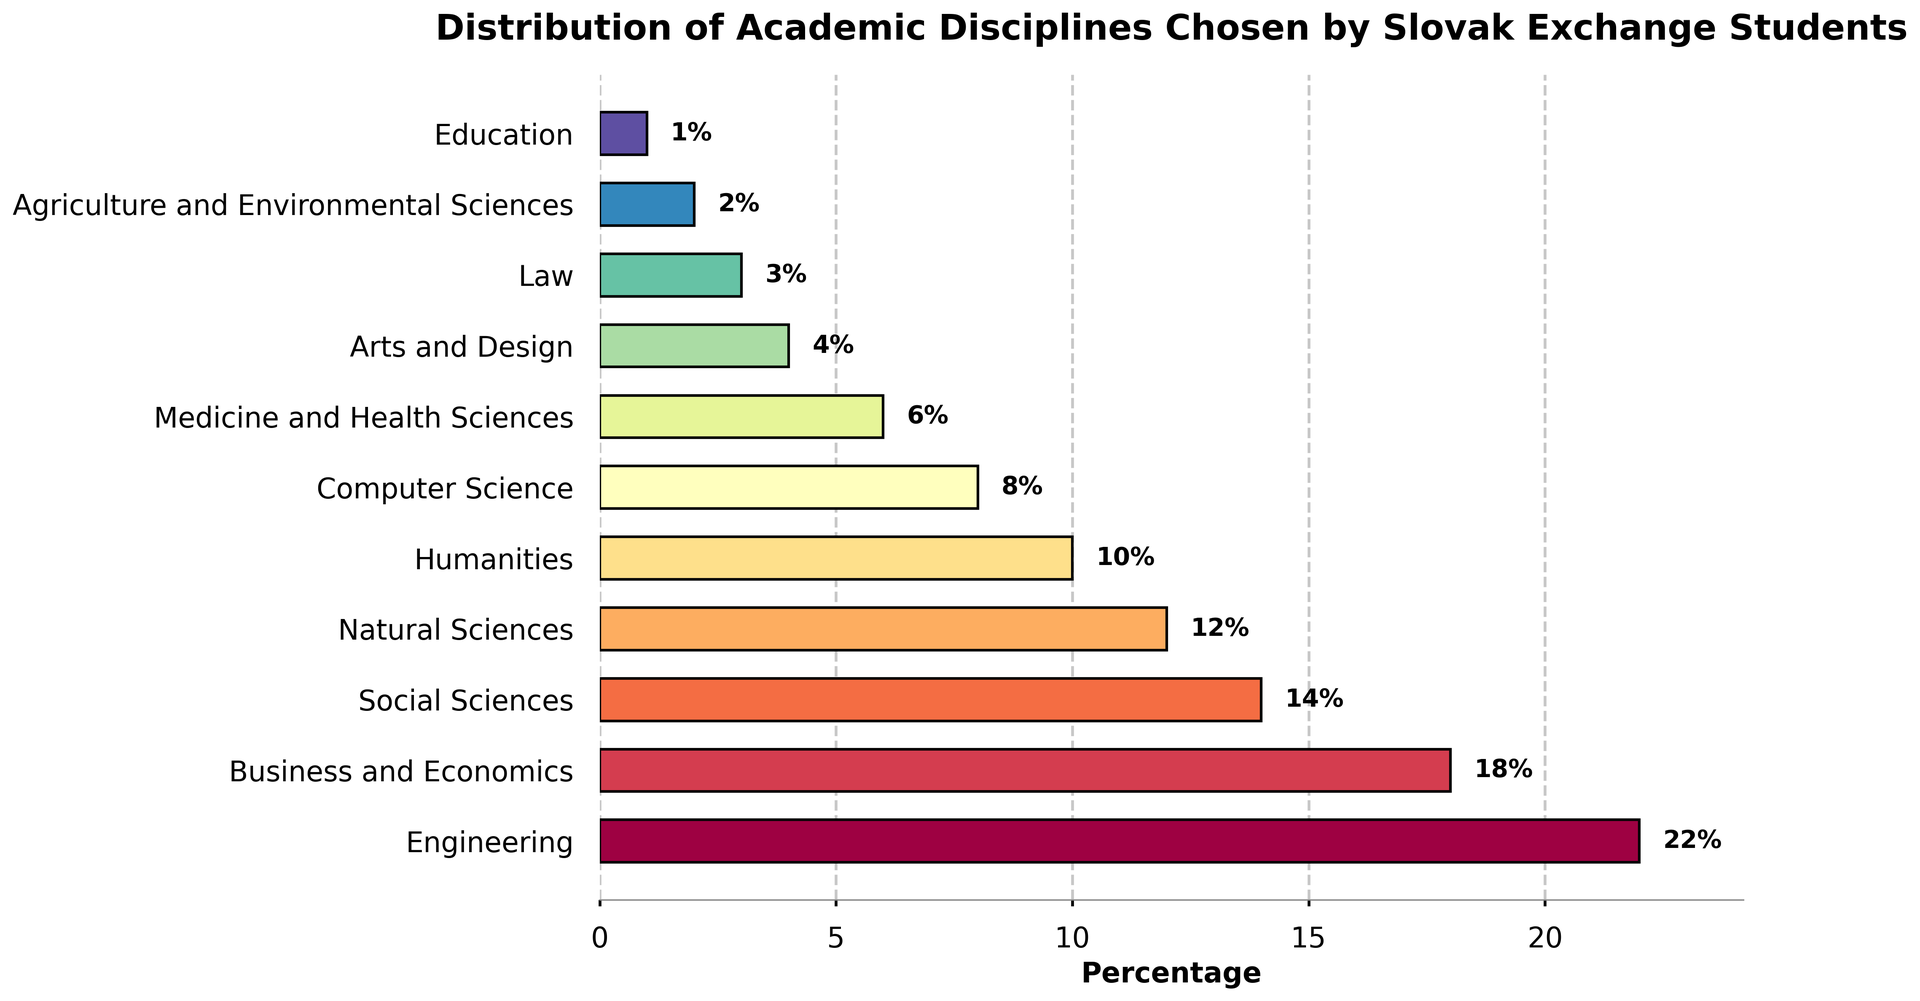Which academic disciplines are chosen by more than 15% of the Slovak exchange students? The bar chart shows the percentage of Slovak exchange students in each academic discipline. Among the disciplines, those with percentages greater than 15% can be identified easily by looking at the data labels. Engineering (22%) and Business and Economics (18%) are chosen by more than 15%.
Answer: Engineering, Business and Economics What is the combined percentage of students choosing Social Sciences and Natural Sciences? To find the combined percentage, sum the percentages of Social Sciences (14%) and Natural Sciences (12%). 14 + 12 = 26.
Answer: 26% Which discipline has the lowest percentage of Slovak exchange students, and what is that percentage? By comparing the lengths and labels of the bars, we see that Education has the shortest bar, indicating the lowest percentage. The label for Education shows 1%.
Answer: Education, 1% How much higher is the percentage of Engineering students compared to Computer Science students? The percentage of students in Engineering is 22%, while in Computer Science, it is 8%. The difference can be calculated as 22 - 8 = 14.
Answer: 14% Which disciplines have equal or less than 4% of Slovak exchange students choosing them? By observing the bar lengths and data labels, the disciplines with 4% or less are Arts and Design (4%), Law (3%), Agriculture and Environmental Sciences (2%), and Education (1%).
Answer: Arts and Design, Law, Agriculture and Environmental Sciences, Education What percentage of students choose either Medicine and Health Sciences or Engineering? This requires summing the percentages for Medicine and Health Sciences (6%) and Engineering (22%). 6 + 22 = 28.
Answer: 28% What is the difference in percentage points between the top two chosen disciplines? The top two disciplines are Engineering (22%) and Business and Economics (18%). The difference is 22 - 18 = 4.
Answer: 4 If we group Humanities and Arts and Design together, what percentage of students choose these fields combined? Combine the percentages for Humanities (10%) and Arts and Design (4%). 10 + 4 = 14.
Answer: 14% What is the total percentage of students who choose disciplines outside the top four most popular ones? The top four disciplines are Engineering (22%), Business and Economics (18%), Social Sciences (14%), and Natural Sciences (12%). Sum these to get the top four percentage: 22 + 18 + 14 + 12 = 66. Subtract this from 100 to get the remaining percentage, 100 - 66 = 34.
Answer: 34% 